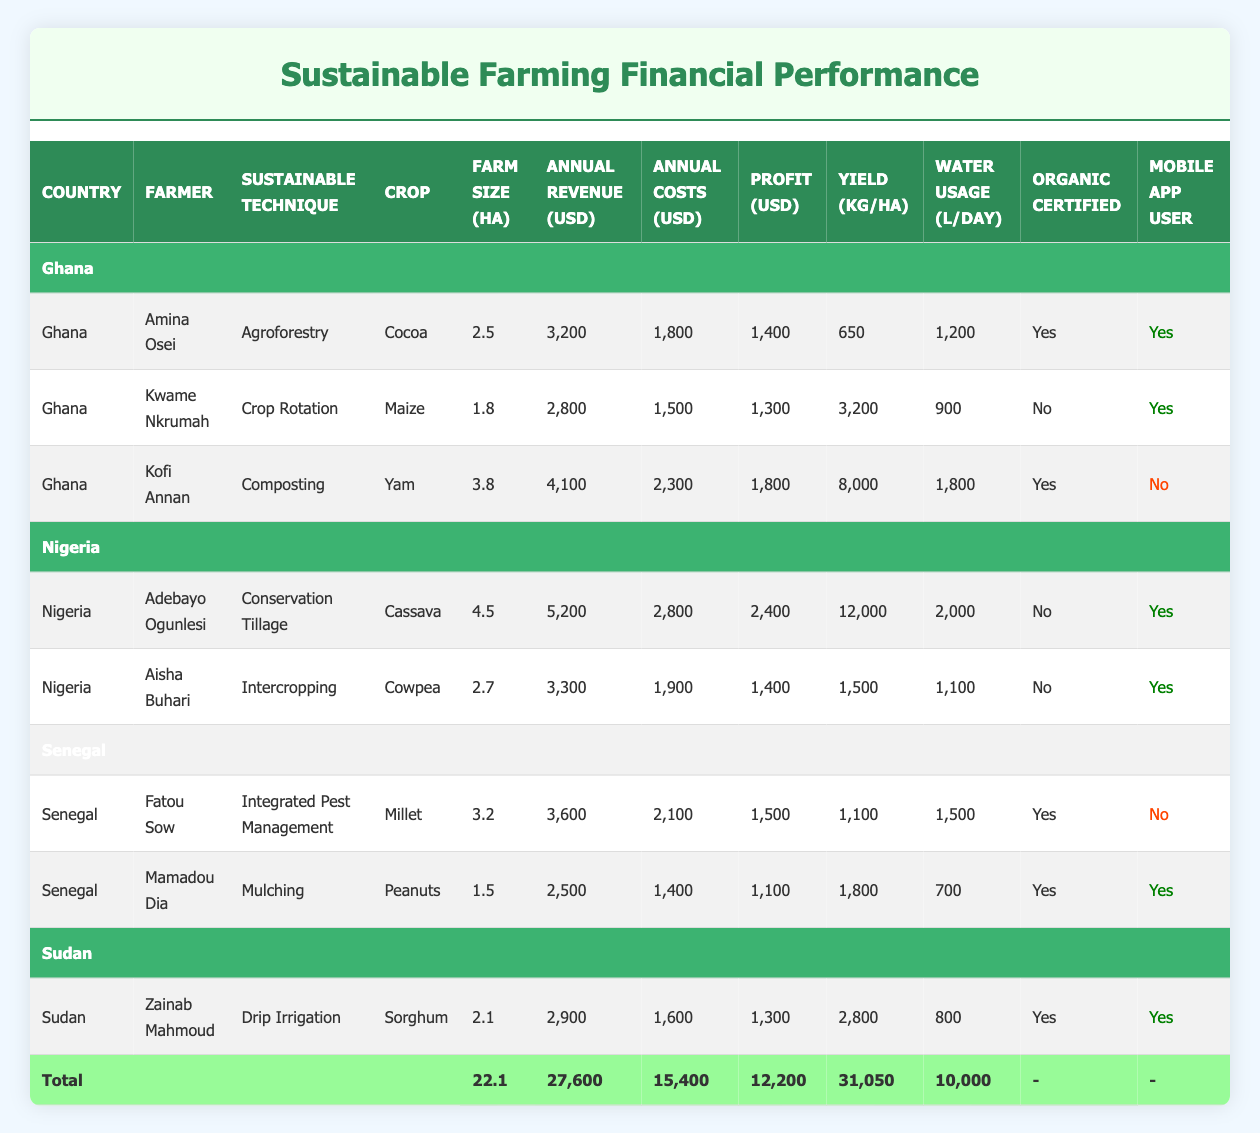What is the total annual revenue generated by farmers in Ghana? To find the total annual revenue for Ghanaian farmers, I sum the annual revenue values from the rows labeled "Ghana". The values are 3200, 2800, and 4100. Thus, 3200 + 2800 + 4100 = 10100.
Answer: 10100 Which farmer has the highest yield per hectare and what is that yield? I compare the yield values for all farmers. The highest yield is found in Adebayo Ogunlesi from Nigeria, with a yield of 12000 kg per hectare.
Answer: 12000 kg Is Zainab Mahmoud an organic certified farmer? I check the organic certification column for Zainab Mahmoud and see "Yes," indicating that she is an organic certified farmer.
Answer: Yes What is the average annual cost of farming for all farmers listed? To calculate the average, I first sum the annual costs of all farmers: 1800 + 1500 + 2100 + 2800 + 1600 + 2300 + 1900 + 1400 = 15000. Then, I divide by the number of farmers, which is 8: 15000 / 8 = 1875.
Answer: 1875 How many farmers use mobile apps for their farming practices? I count the number of farmers marked as mobile app users. There are 5 farmers with "Yes" in the mobile app user column.
Answer: 5 What is the difference in annual revenue between the highest and lowest earning farmers in the table? I identify Adebayo Ogunlesi as the highest earner with 5200 and Mamadou Dia as the lowest with 2500. The difference is 5200 - 2500 = 2700.
Answer: 2700 Which crop has the highest revenue generated among the listed farmers? I look at the annual revenue for each crop. Adebayo Ogunlesi's cassava generates the highest revenue at 5200 USD, compared to other crops.
Answer: Cassava How many farmers have organic certification and also use mobile applications? I analyze the table for farmers marked "Yes" in both the organic certification and mobile app user columns. Amina Osei and Mamadou Dia meet these criteria, yielding a total of 2 farmers.
Answer: 2 